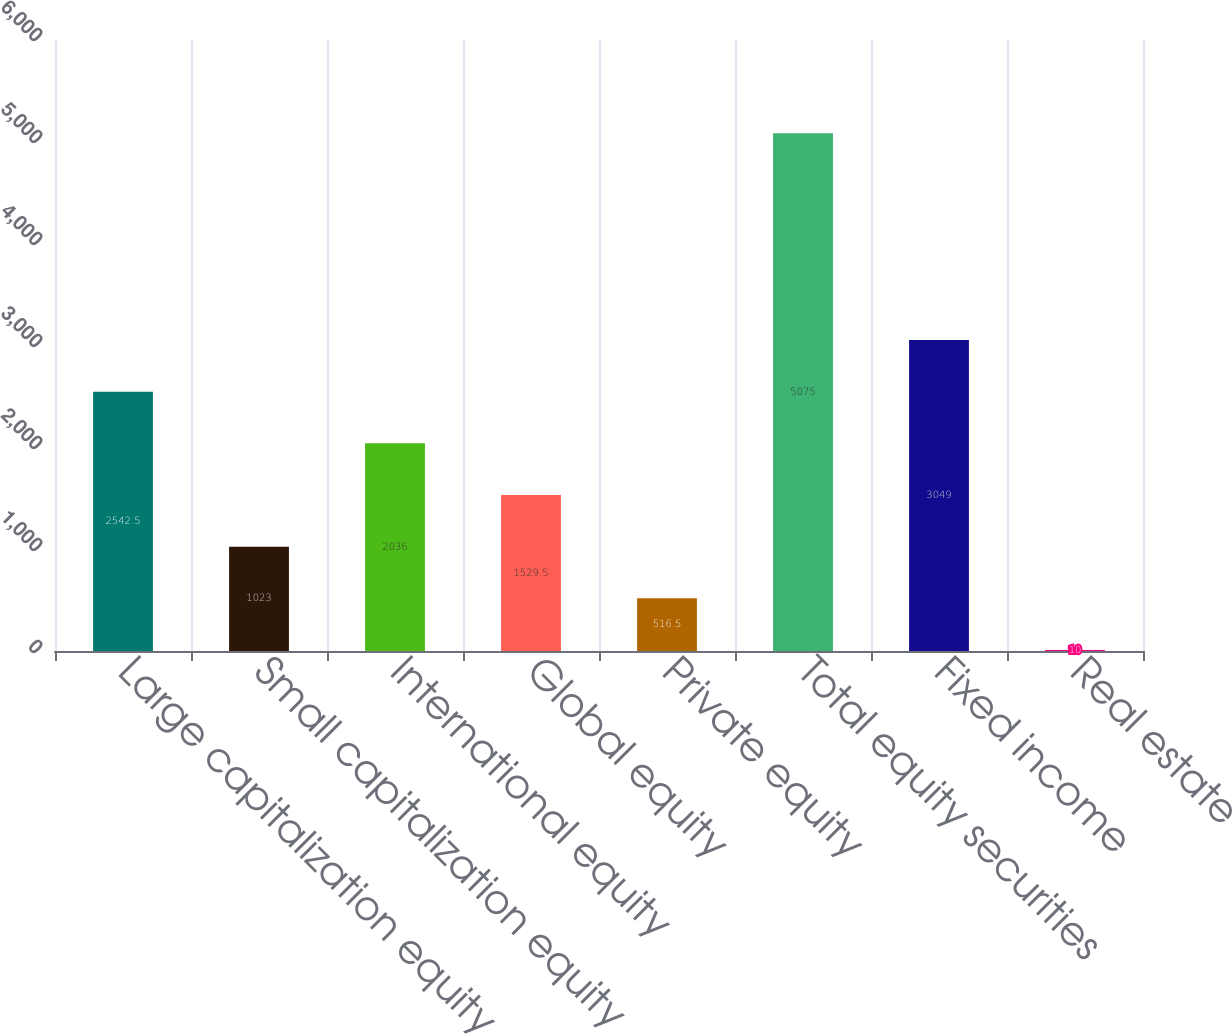<chart> <loc_0><loc_0><loc_500><loc_500><bar_chart><fcel>Large capitalization equity<fcel>Small capitalization equity<fcel>International equity<fcel>Global equity<fcel>Private equity<fcel>Total equity securities<fcel>Fixed income<fcel>Real estate<nl><fcel>2542.5<fcel>1023<fcel>2036<fcel>1529.5<fcel>516.5<fcel>5075<fcel>3049<fcel>10<nl></chart> 